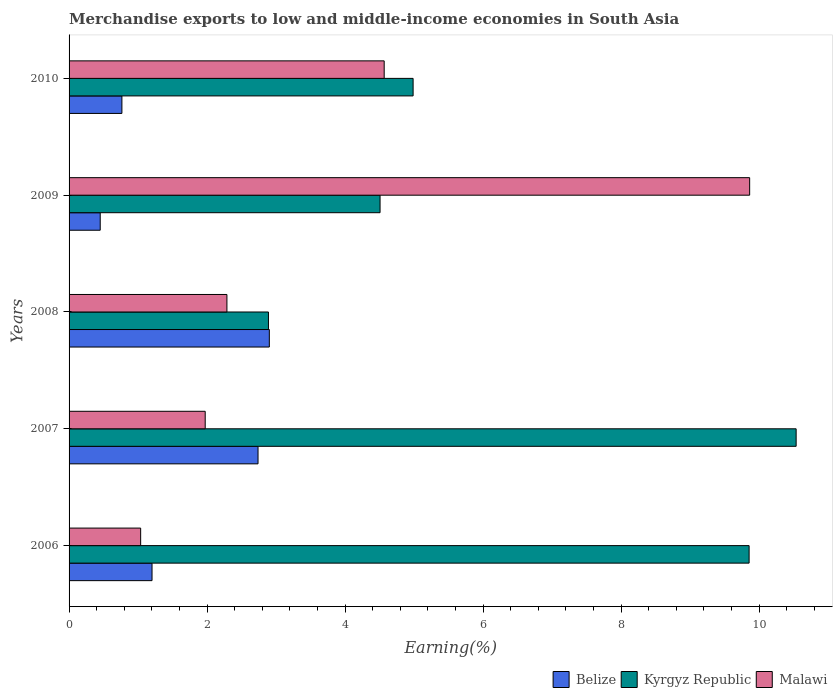How many different coloured bars are there?
Offer a terse response. 3. Are the number of bars per tick equal to the number of legend labels?
Ensure brevity in your answer.  Yes. Are the number of bars on each tick of the Y-axis equal?
Provide a succinct answer. Yes. How many bars are there on the 2nd tick from the top?
Keep it short and to the point. 3. What is the label of the 1st group of bars from the top?
Provide a succinct answer. 2010. In how many cases, is the number of bars for a given year not equal to the number of legend labels?
Your answer should be compact. 0. What is the percentage of amount earned from merchandise exports in Kyrgyz Republic in 2006?
Your answer should be compact. 9.85. Across all years, what is the maximum percentage of amount earned from merchandise exports in Malawi?
Provide a succinct answer. 9.86. Across all years, what is the minimum percentage of amount earned from merchandise exports in Belize?
Offer a terse response. 0.45. In which year was the percentage of amount earned from merchandise exports in Malawi maximum?
Ensure brevity in your answer.  2009. What is the total percentage of amount earned from merchandise exports in Kyrgyz Republic in the graph?
Your answer should be compact. 32.77. What is the difference between the percentage of amount earned from merchandise exports in Belize in 2007 and that in 2010?
Make the answer very short. 1.97. What is the difference between the percentage of amount earned from merchandise exports in Malawi in 2008 and the percentage of amount earned from merchandise exports in Belize in 2007?
Offer a very short reply. -0.45. What is the average percentage of amount earned from merchandise exports in Kyrgyz Republic per year?
Give a very brief answer. 6.55. In the year 2009, what is the difference between the percentage of amount earned from merchandise exports in Malawi and percentage of amount earned from merchandise exports in Kyrgyz Republic?
Your response must be concise. 5.36. What is the ratio of the percentage of amount earned from merchandise exports in Malawi in 2006 to that in 2010?
Make the answer very short. 0.23. Is the percentage of amount earned from merchandise exports in Kyrgyz Republic in 2006 less than that in 2008?
Your answer should be compact. No. Is the difference between the percentage of amount earned from merchandise exports in Malawi in 2008 and 2010 greater than the difference between the percentage of amount earned from merchandise exports in Kyrgyz Republic in 2008 and 2010?
Offer a terse response. No. What is the difference between the highest and the second highest percentage of amount earned from merchandise exports in Belize?
Your response must be concise. 0.16. What is the difference between the highest and the lowest percentage of amount earned from merchandise exports in Belize?
Keep it short and to the point. 2.45. In how many years, is the percentage of amount earned from merchandise exports in Malawi greater than the average percentage of amount earned from merchandise exports in Malawi taken over all years?
Keep it short and to the point. 2. Is the sum of the percentage of amount earned from merchandise exports in Kyrgyz Republic in 2008 and 2009 greater than the maximum percentage of amount earned from merchandise exports in Belize across all years?
Provide a short and direct response. Yes. What does the 1st bar from the top in 2006 represents?
Your response must be concise. Malawi. What does the 3rd bar from the bottom in 2006 represents?
Keep it short and to the point. Malawi. How many bars are there?
Your answer should be compact. 15. What is the difference between two consecutive major ticks on the X-axis?
Keep it short and to the point. 2. Are the values on the major ticks of X-axis written in scientific E-notation?
Offer a terse response. No. Does the graph contain any zero values?
Your answer should be compact. No. Does the graph contain grids?
Ensure brevity in your answer.  No. How many legend labels are there?
Keep it short and to the point. 3. How are the legend labels stacked?
Your response must be concise. Horizontal. What is the title of the graph?
Provide a succinct answer. Merchandise exports to low and middle-income economies in South Asia. What is the label or title of the X-axis?
Provide a short and direct response. Earning(%). What is the label or title of the Y-axis?
Make the answer very short. Years. What is the Earning(%) in Belize in 2006?
Offer a terse response. 1.2. What is the Earning(%) in Kyrgyz Republic in 2006?
Ensure brevity in your answer.  9.85. What is the Earning(%) in Malawi in 2006?
Make the answer very short. 1.04. What is the Earning(%) in Belize in 2007?
Your response must be concise. 2.74. What is the Earning(%) of Kyrgyz Republic in 2007?
Provide a short and direct response. 10.54. What is the Earning(%) in Malawi in 2007?
Make the answer very short. 1.97. What is the Earning(%) of Belize in 2008?
Your answer should be very brief. 2.9. What is the Earning(%) in Kyrgyz Republic in 2008?
Offer a terse response. 2.89. What is the Earning(%) of Malawi in 2008?
Your response must be concise. 2.29. What is the Earning(%) in Belize in 2009?
Your answer should be compact. 0.45. What is the Earning(%) of Kyrgyz Republic in 2009?
Your response must be concise. 4.51. What is the Earning(%) in Malawi in 2009?
Offer a terse response. 9.86. What is the Earning(%) in Belize in 2010?
Your answer should be compact. 0.77. What is the Earning(%) in Kyrgyz Republic in 2010?
Your answer should be very brief. 4.99. What is the Earning(%) in Malawi in 2010?
Your answer should be compact. 4.57. Across all years, what is the maximum Earning(%) of Belize?
Your answer should be compact. 2.9. Across all years, what is the maximum Earning(%) in Kyrgyz Republic?
Make the answer very short. 10.54. Across all years, what is the maximum Earning(%) in Malawi?
Your answer should be very brief. 9.86. Across all years, what is the minimum Earning(%) of Belize?
Give a very brief answer. 0.45. Across all years, what is the minimum Earning(%) in Kyrgyz Republic?
Provide a short and direct response. 2.89. Across all years, what is the minimum Earning(%) in Malawi?
Ensure brevity in your answer.  1.04. What is the total Earning(%) in Belize in the graph?
Provide a succinct answer. 8.06. What is the total Earning(%) of Kyrgyz Republic in the graph?
Your response must be concise. 32.77. What is the total Earning(%) in Malawi in the graph?
Offer a terse response. 19.73. What is the difference between the Earning(%) of Belize in 2006 and that in 2007?
Your answer should be compact. -1.54. What is the difference between the Earning(%) of Kyrgyz Republic in 2006 and that in 2007?
Make the answer very short. -0.68. What is the difference between the Earning(%) in Malawi in 2006 and that in 2007?
Make the answer very short. -0.94. What is the difference between the Earning(%) of Belize in 2006 and that in 2008?
Ensure brevity in your answer.  -1.7. What is the difference between the Earning(%) in Kyrgyz Republic in 2006 and that in 2008?
Make the answer very short. 6.97. What is the difference between the Earning(%) of Malawi in 2006 and that in 2008?
Offer a very short reply. -1.25. What is the difference between the Earning(%) in Belize in 2006 and that in 2009?
Provide a succinct answer. 0.75. What is the difference between the Earning(%) in Kyrgyz Republic in 2006 and that in 2009?
Keep it short and to the point. 5.35. What is the difference between the Earning(%) in Malawi in 2006 and that in 2009?
Make the answer very short. -8.82. What is the difference between the Earning(%) in Belize in 2006 and that in 2010?
Keep it short and to the point. 0.44. What is the difference between the Earning(%) in Kyrgyz Republic in 2006 and that in 2010?
Give a very brief answer. 4.87. What is the difference between the Earning(%) in Malawi in 2006 and that in 2010?
Provide a succinct answer. -3.53. What is the difference between the Earning(%) in Belize in 2007 and that in 2008?
Provide a short and direct response. -0.16. What is the difference between the Earning(%) in Kyrgyz Republic in 2007 and that in 2008?
Keep it short and to the point. 7.65. What is the difference between the Earning(%) in Malawi in 2007 and that in 2008?
Provide a short and direct response. -0.31. What is the difference between the Earning(%) in Belize in 2007 and that in 2009?
Ensure brevity in your answer.  2.29. What is the difference between the Earning(%) of Kyrgyz Republic in 2007 and that in 2009?
Provide a short and direct response. 6.03. What is the difference between the Earning(%) of Malawi in 2007 and that in 2009?
Your answer should be very brief. -7.89. What is the difference between the Earning(%) of Belize in 2007 and that in 2010?
Keep it short and to the point. 1.97. What is the difference between the Earning(%) in Kyrgyz Republic in 2007 and that in 2010?
Give a very brief answer. 5.55. What is the difference between the Earning(%) in Malawi in 2007 and that in 2010?
Provide a succinct answer. -2.59. What is the difference between the Earning(%) in Belize in 2008 and that in 2009?
Your response must be concise. 2.45. What is the difference between the Earning(%) in Kyrgyz Republic in 2008 and that in 2009?
Provide a succinct answer. -1.62. What is the difference between the Earning(%) in Malawi in 2008 and that in 2009?
Ensure brevity in your answer.  -7.57. What is the difference between the Earning(%) in Belize in 2008 and that in 2010?
Offer a terse response. 2.14. What is the difference between the Earning(%) of Kyrgyz Republic in 2008 and that in 2010?
Keep it short and to the point. -2.1. What is the difference between the Earning(%) of Malawi in 2008 and that in 2010?
Provide a succinct answer. -2.28. What is the difference between the Earning(%) of Belize in 2009 and that in 2010?
Give a very brief answer. -0.31. What is the difference between the Earning(%) in Kyrgyz Republic in 2009 and that in 2010?
Provide a short and direct response. -0.48. What is the difference between the Earning(%) of Malawi in 2009 and that in 2010?
Provide a succinct answer. 5.3. What is the difference between the Earning(%) in Belize in 2006 and the Earning(%) in Kyrgyz Republic in 2007?
Your response must be concise. -9.33. What is the difference between the Earning(%) of Belize in 2006 and the Earning(%) of Malawi in 2007?
Your answer should be very brief. -0.77. What is the difference between the Earning(%) of Kyrgyz Republic in 2006 and the Earning(%) of Malawi in 2007?
Your response must be concise. 7.88. What is the difference between the Earning(%) in Belize in 2006 and the Earning(%) in Kyrgyz Republic in 2008?
Provide a short and direct response. -1.69. What is the difference between the Earning(%) of Belize in 2006 and the Earning(%) of Malawi in 2008?
Your answer should be very brief. -1.09. What is the difference between the Earning(%) in Kyrgyz Republic in 2006 and the Earning(%) in Malawi in 2008?
Provide a short and direct response. 7.57. What is the difference between the Earning(%) of Belize in 2006 and the Earning(%) of Kyrgyz Republic in 2009?
Your response must be concise. -3.3. What is the difference between the Earning(%) in Belize in 2006 and the Earning(%) in Malawi in 2009?
Provide a succinct answer. -8.66. What is the difference between the Earning(%) of Kyrgyz Republic in 2006 and the Earning(%) of Malawi in 2009?
Your answer should be very brief. -0.01. What is the difference between the Earning(%) in Belize in 2006 and the Earning(%) in Kyrgyz Republic in 2010?
Keep it short and to the point. -3.78. What is the difference between the Earning(%) in Belize in 2006 and the Earning(%) in Malawi in 2010?
Offer a very short reply. -3.36. What is the difference between the Earning(%) of Kyrgyz Republic in 2006 and the Earning(%) of Malawi in 2010?
Your response must be concise. 5.29. What is the difference between the Earning(%) in Belize in 2007 and the Earning(%) in Kyrgyz Republic in 2008?
Ensure brevity in your answer.  -0.15. What is the difference between the Earning(%) in Belize in 2007 and the Earning(%) in Malawi in 2008?
Your response must be concise. 0.45. What is the difference between the Earning(%) in Kyrgyz Republic in 2007 and the Earning(%) in Malawi in 2008?
Keep it short and to the point. 8.25. What is the difference between the Earning(%) in Belize in 2007 and the Earning(%) in Kyrgyz Republic in 2009?
Give a very brief answer. -1.77. What is the difference between the Earning(%) in Belize in 2007 and the Earning(%) in Malawi in 2009?
Offer a very short reply. -7.12. What is the difference between the Earning(%) of Kyrgyz Republic in 2007 and the Earning(%) of Malawi in 2009?
Provide a succinct answer. 0.67. What is the difference between the Earning(%) of Belize in 2007 and the Earning(%) of Kyrgyz Republic in 2010?
Your response must be concise. -2.25. What is the difference between the Earning(%) in Belize in 2007 and the Earning(%) in Malawi in 2010?
Offer a very short reply. -1.83. What is the difference between the Earning(%) of Kyrgyz Republic in 2007 and the Earning(%) of Malawi in 2010?
Offer a very short reply. 5.97. What is the difference between the Earning(%) of Belize in 2008 and the Earning(%) of Kyrgyz Republic in 2009?
Your answer should be compact. -1.6. What is the difference between the Earning(%) in Belize in 2008 and the Earning(%) in Malawi in 2009?
Your answer should be very brief. -6.96. What is the difference between the Earning(%) of Kyrgyz Republic in 2008 and the Earning(%) of Malawi in 2009?
Offer a very short reply. -6.97. What is the difference between the Earning(%) in Belize in 2008 and the Earning(%) in Kyrgyz Republic in 2010?
Ensure brevity in your answer.  -2.08. What is the difference between the Earning(%) of Belize in 2008 and the Earning(%) of Malawi in 2010?
Your response must be concise. -1.66. What is the difference between the Earning(%) in Kyrgyz Republic in 2008 and the Earning(%) in Malawi in 2010?
Your answer should be compact. -1.68. What is the difference between the Earning(%) in Belize in 2009 and the Earning(%) in Kyrgyz Republic in 2010?
Ensure brevity in your answer.  -4.53. What is the difference between the Earning(%) of Belize in 2009 and the Earning(%) of Malawi in 2010?
Offer a very short reply. -4.11. What is the difference between the Earning(%) in Kyrgyz Republic in 2009 and the Earning(%) in Malawi in 2010?
Provide a short and direct response. -0.06. What is the average Earning(%) of Belize per year?
Keep it short and to the point. 1.61. What is the average Earning(%) of Kyrgyz Republic per year?
Keep it short and to the point. 6.55. What is the average Earning(%) of Malawi per year?
Give a very brief answer. 3.95. In the year 2006, what is the difference between the Earning(%) in Belize and Earning(%) in Kyrgyz Republic?
Keep it short and to the point. -8.65. In the year 2006, what is the difference between the Earning(%) of Belize and Earning(%) of Malawi?
Your answer should be compact. 0.16. In the year 2006, what is the difference between the Earning(%) in Kyrgyz Republic and Earning(%) in Malawi?
Offer a very short reply. 8.82. In the year 2007, what is the difference between the Earning(%) in Belize and Earning(%) in Kyrgyz Republic?
Make the answer very short. -7.8. In the year 2007, what is the difference between the Earning(%) of Belize and Earning(%) of Malawi?
Ensure brevity in your answer.  0.77. In the year 2007, what is the difference between the Earning(%) of Kyrgyz Republic and Earning(%) of Malawi?
Make the answer very short. 8.56. In the year 2008, what is the difference between the Earning(%) in Belize and Earning(%) in Kyrgyz Republic?
Give a very brief answer. 0.01. In the year 2008, what is the difference between the Earning(%) of Belize and Earning(%) of Malawi?
Provide a short and direct response. 0.61. In the year 2008, what is the difference between the Earning(%) of Kyrgyz Republic and Earning(%) of Malawi?
Your response must be concise. 0.6. In the year 2009, what is the difference between the Earning(%) of Belize and Earning(%) of Kyrgyz Republic?
Offer a terse response. -4.06. In the year 2009, what is the difference between the Earning(%) in Belize and Earning(%) in Malawi?
Give a very brief answer. -9.41. In the year 2009, what is the difference between the Earning(%) in Kyrgyz Republic and Earning(%) in Malawi?
Provide a succinct answer. -5.36. In the year 2010, what is the difference between the Earning(%) in Belize and Earning(%) in Kyrgyz Republic?
Make the answer very short. -4.22. In the year 2010, what is the difference between the Earning(%) in Belize and Earning(%) in Malawi?
Ensure brevity in your answer.  -3.8. In the year 2010, what is the difference between the Earning(%) in Kyrgyz Republic and Earning(%) in Malawi?
Your answer should be very brief. 0.42. What is the ratio of the Earning(%) of Belize in 2006 to that in 2007?
Keep it short and to the point. 0.44. What is the ratio of the Earning(%) in Kyrgyz Republic in 2006 to that in 2007?
Your answer should be very brief. 0.94. What is the ratio of the Earning(%) of Malawi in 2006 to that in 2007?
Give a very brief answer. 0.53. What is the ratio of the Earning(%) of Belize in 2006 to that in 2008?
Provide a succinct answer. 0.41. What is the ratio of the Earning(%) of Kyrgyz Republic in 2006 to that in 2008?
Make the answer very short. 3.41. What is the ratio of the Earning(%) of Malawi in 2006 to that in 2008?
Offer a very short reply. 0.45. What is the ratio of the Earning(%) in Belize in 2006 to that in 2009?
Offer a very short reply. 2.66. What is the ratio of the Earning(%) in Kyrgyz Republic in 2006 to that in 2009?
Provide a succinct answer. 2.19. What is the ratio of the Earning(%) in Malawi in 2006 to that in 2009?
Ensure brevity in your answer.  0.11. What is the ratio of the Earning(%) of Belize in 2006 to that in 2010?
Your response must be concise. 1.57. What is the ratio of the Earning(%) in Kyrgyz Republic in 2006 to that in 2010?
Keep it short and to the point. 1.98. What is the ratio of the Earning(%) of Malawi in 2006 to that in 2010?
Your response must be concise. 0.23. What is the ratio of the Earning(%) in Belize in 2007 to that in 2008?
Your response must be concise. 0.94. What is the ratio of the Earning(%) of Kyrgyz Republic in 2007 to that in 2008?
Give a very brief answer. 3.65. What is the ratio of the Earning(%) of Malawi in 2007 to that in 2008?
Ensure brevity in your answer.  0.86. What is the ratio of the Earning(%) in Belize in 2007 to that in 2009?
Ensure brevity in your answer.  6.07. What is the ratio of the Earning(%) of Kyrgyz Republic in 2007 to that in 2009?
Make the answer very short. 2.34. What is the ratio of the Earning(%) of Belize in 2007 to that in 2010?
Ensure brevity in your answer.  3.58. What is the ratio of the Earning(%) in Kyrgyz Republic in 2007 to that in 2010?
Offer a terse response. 2.11. What is the ratio of the Earning(%) of Malawi in 2007 to that in 2010?
Make the answer very short. 0.43. What is the ratio of the Earning(%) in Belize in 2008 to that in 2009?
Your response must be concise. 6.43. What is the ratio of the Earning(%) of Kyrgyz Republic in 2008 to that in 2009?
Your answer should be very brief. 0.64. What is the ratio of the Earning(%) in Malawi in 2008 to that in 2009?
Your answer should be very brief. 0.23. What is the ratio of the Earning(%) in Belize in 2008 to that in 2010?
Ensure brevity in your answer.  3.79. What is the ratio of the Earning(%) in Kyrgyz Republic in 2008 to that in 2010?
Your answer should be very brief. 0.58. What is the ratio of the Earning(%) in Malawi in 2008 to that in 2010?
Make the answer very short. 0.5. What is the ratio of the Earning(%) in Belize in 2009 to that in 2010?
Your answer should be very brief. 0.59. What is the ratio of the Earning(%) in Kyrgyz Republic in 2009 to that in 2010?
Your answer should be very brief. 0.9. What is the ratio of the Earning(%) of Malawi in 2009 to that in 2010?
Offer a very short reply. 2.16. What is the difference between the highest and the second highest Earning(%) in Belize?
Provide a short and direct response. 0.16. What is the difference between the highest and the second highest Earning(%) of Kyrgyz Republic?
Offer a very short reply. 0.68. What is the difference between the highest and the second highest Earning(%) of Malawi?
Keep it short and to the point. 5.3. What is the difference between the highest and the lowest Earning(%) in Belize?
Provide a succinct answer. 2.45. What is the difference between the highest and the lowest Earning(%) in Kyrgyz Republic?
Make the answer very short. 7.65. What is the difference between the highest and the lowest Earning(%) of Malawi?
Provide a short and direct response. 8.82. 